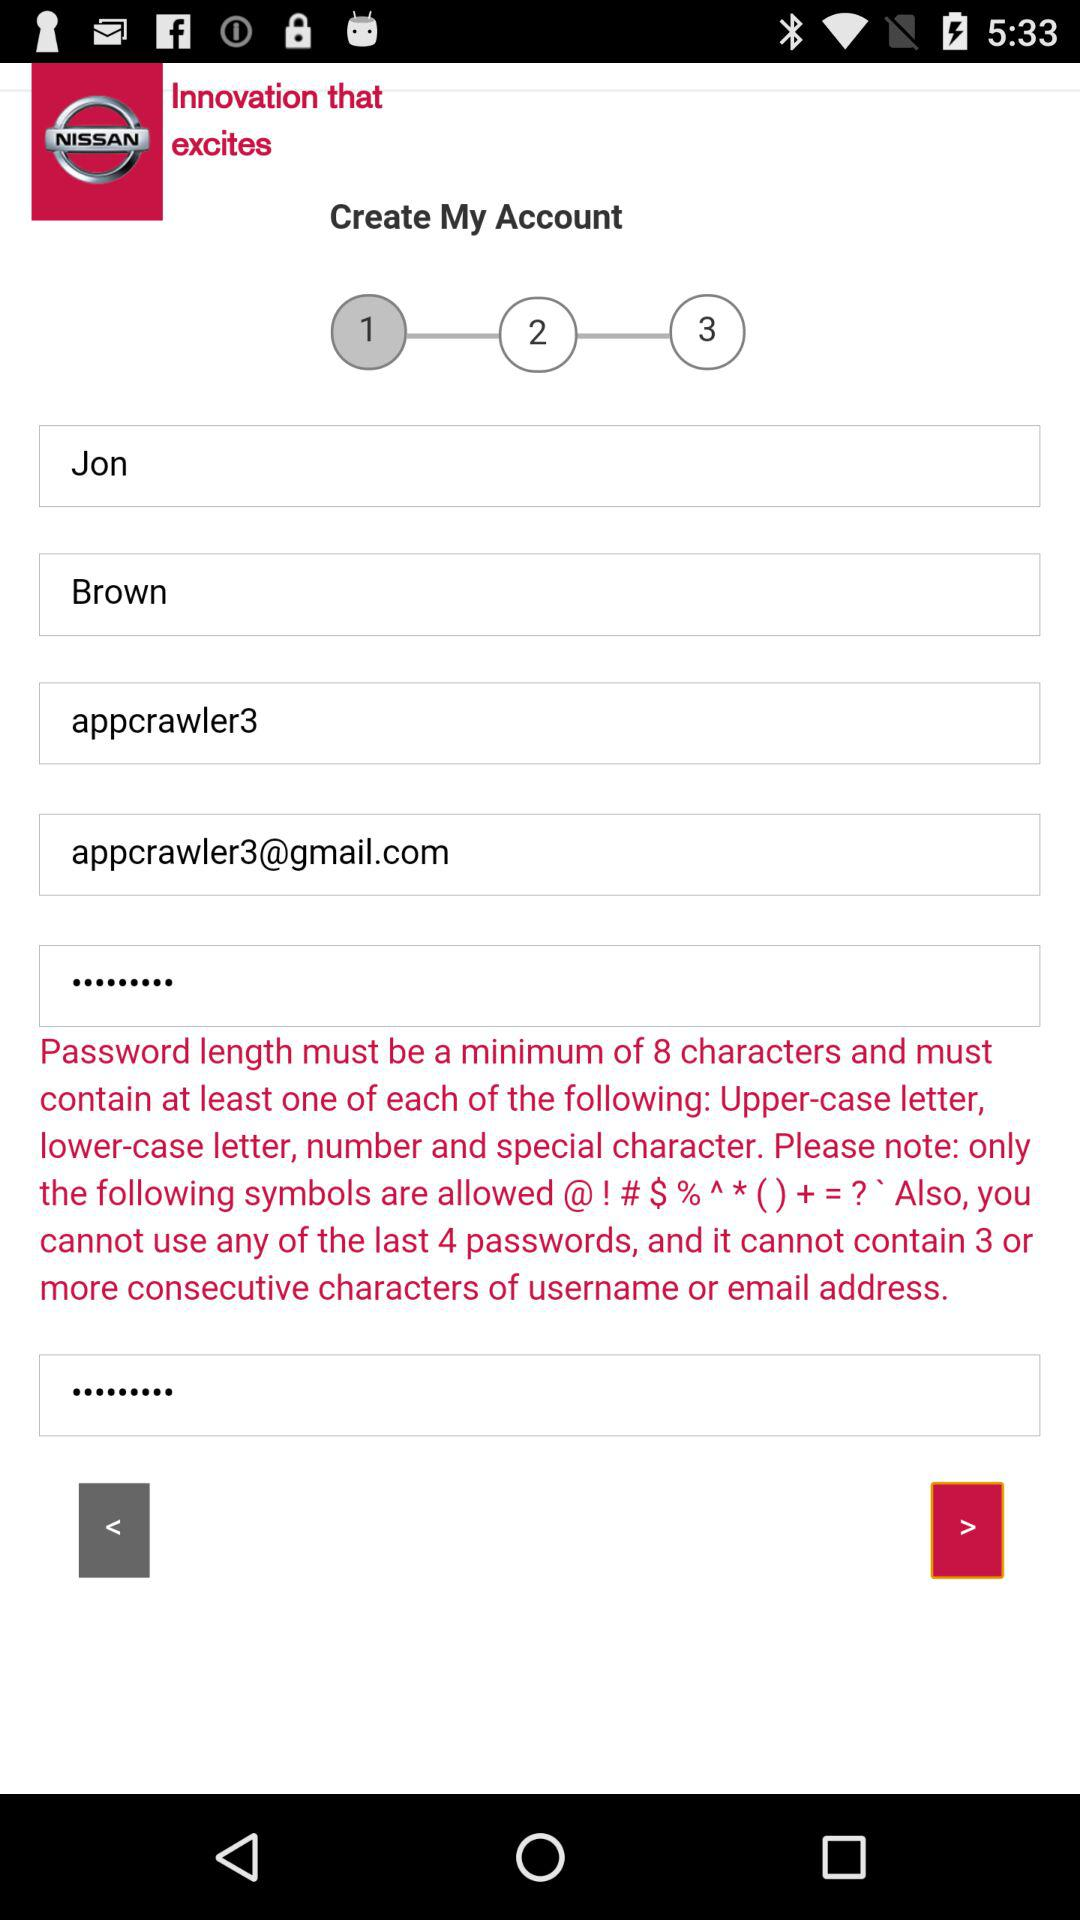What is the minimum length of the password? The minimum length of the password is 8 characters. 